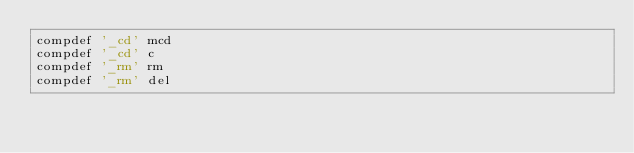Convert code to text. <code><loc_0><loc_0><loc_500><loc_500><_Bash_>compdef '_cd' mcd
compdef '_cd' c
compdef '_rm' rm
compdef '_rm' del
</code> 